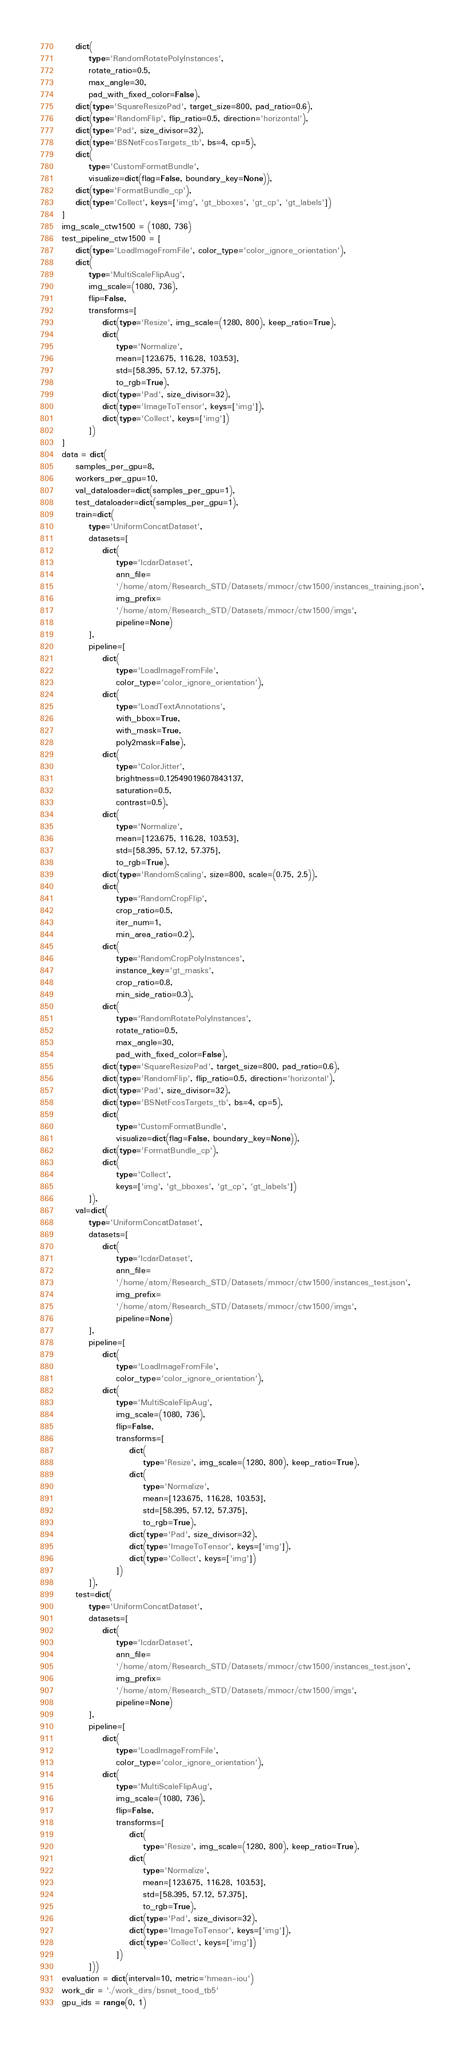Convert code to text. <code><loc_0><loc_0><loc_500><loc_500><_Python_>    dict(
        type='RandomRotatePolyInstances',
        rotate_ratio=0.5,
        max_angle=30,
        pad_with_fixed_color=False),
    dict(type='SquareResizePad', target_size=800, pad_ratio=0.6),
    dict(type='RandomFlip', flip_ratio=0.5, direction='horizontal'),
    dict(type='Pad', size_divisor=32),
    dict(type='BSNetFcosTargets_tb', bs=4, cp=5),
    dict(
        type='CustomFormatBundle',
        visualize=dict(flag=False, boundary_key=None)),
    dict(type='FormatBundle_cp'),
    dict(type='Collect', keys=['img', 'gt_bboxes', 'gt_cp', 'gt_labels'])
]
img_scale_ctw1500 = (1080, 736)
test_pipeline_ctw1500 = [
    dict(type='LoadImageFromFile', color_type='color_ignore_orientation'),
    dict(
        type='MultiScaleFlipAug',
        img_scale=(1080, 736),
        flip=False,
        transforms=[
            dict(type='Resize', img_scale=(1280, 800), keep_ratio=True),
            dict(
                type='Normalize',
                mean=[123.675, 116.28, 103.53],
                std=[58.395, 57.12, 57.375],
                to_rgb=True),
            dict(type='Pad', size_divisor=32),
            dict(type='ImageToTensor', keys=['img']),
            dict(type='Collect', keys=['img'])
        ])
]
data = dict(
    samples_per_gpu=8,
    workers_per_gpu=10,
    val_dataloader=dict(samples_per_gpu=1),
    test_dataloader=dict(samples_per_gpu=1),
    train=dict(
        type='UniformConcatDataset',
        datasets=[
            dict(
                type='IcdarDataset',
                ann_file=
                '/home/atom/Research_STD/Datasets/mmocr/ctw1500/instances_training.json',
                img_prefix=
                '/home/atom/Research_STD/Datasets/mmocr/ctw1500/imgs',
                pipeline=None)
        ],
        pipeline=[
            dict(
                type='LoadImageFromFile',
                color_type='color_ignore_orientation'),
            dict(
                type='LoadTextAnnotations',
                with_bbox=True,
                with_mask=True,
                poly2mask=False),
            dict(
                type='ColorJitter',
                brightness=0.12549019607843137,
                saturation=0.5,
                contrast=0.5),
            dict(
                type='Normalize',
                mean=[123.675, 116.28, 103.53],
                std=[58.395, 57.12, 57.375],
                to_rgb=True),
            dict(type='RandomScaling', size=800, scale=(0.75, 2.5)),
            dict(
                type='RandomCropFlip',
                crop_ratio=0.5,
                iter_num=1,
                min_area_ratio=0.2),
            dict(
                type='RandomCropPolyInstances',
                instance_key='gt_masks',
                crop_ratio=0.8,
                min_side_ratio=0.3),
            dict(
                type='RandomRotatePolyInstances',
                rotate_ratio=0.5,
                max_angle=30,
                pad_with_fixed_color=False),
            dict(type='SquareResizePad', target_size=800, pad_ratio=0.6),
            dict(type='RandomFlip', flip_ratio=0.5, direction='horizontal'),
            dict(type='Pad', size_divisor=32),
            dict(type='BSNetFcosTargets_tb', bs=4, cp=5),
            dict(
                type='CustomFormatBundle',
                visualize=dict(flag=False, boundary_key=None)),
            dict(type='FormatBundle_cp'),
            dict(
                type='Collect',
                keys=['img', 'gt_bboxes', 'gt_cp', 'gt_labels'])
        ]),
    val=dict(
        type='UniformConcatDataset',
        datasets=[
            dict(
                type='IcdarDataset',
                ann_file=
                '/home/atom/Research_STD/Datasets/mmocr/ctw1500/instances_test.json',
                img_prefix=
                '/home/atom/Research_STD/Datasets/mmocr/ctw1500/imgs',
                pipeline=None)
        ],
        pipeline=[
            dict(
                type='LoadImageFromFile',
                color_type='color_ignore_orientation'),
            dict(
                type='MultiScaleFlipAug',
                img_scale=(1080, 736),
                flip=False,
                transforms=[
                    dict(
                        type='Resize', img_scale=(1280, 800), keep_ratio=True),
                    dict(
                        type='Normalize',
                        mean=[123.675, 116.28, 103.53],
                        std=[58.395, 57.12, 57.375],
                        to_rgb=True),
                    dict(type='Pad', size_divisor=32),
                    dict(type='ImageToTensor', keys=['img']),
                    dict(type='Collect', keys=['img'])
                ])
        ]),
    test=dict(
        type='UniformConcatDataset',
        datasets=[
            dict(
                type='IcdarDataset',
                ann_file=
                '/home/atom/Research_STD/Datasets/mmocr/ctw1500/instances_test.json',
                img_prefix=
                '/home/atom/Research_STD/Datasets/mmocr/ctw1500/imgs',
                pipeline=None)
        ],
        pipeline=[
            dict(
                type='LoadImageFromFile',
                color_type='color_ignore_orientation'),
            dict(
                type='MultiScaleFlipAug',
                img_scale=(1080, 736),
                flip=False,
                transforms=[
                    dict(
                        type='Resize', img_scale=(1280, 800), keep_ratio=True),
                    dict(
                        type='Normalize',
                        mean=[123.675, 116.28, 103.53],
                        std=[58.395, 57.12, 57.375],
                        to_rgb=True),
                    dict(type='Pad', size_divisor=32),
                    dict(type='ImageToTensor', keys=['img']),
                    dict(type='Collect', keys=['img'])
                ])
        ]))
evaluation = dict(interval=10, metric='hmean-iou')
work_dir = './work_dirs/bsnet_tood_tb5'
gpu_ids = range(0, 1)
</code> 